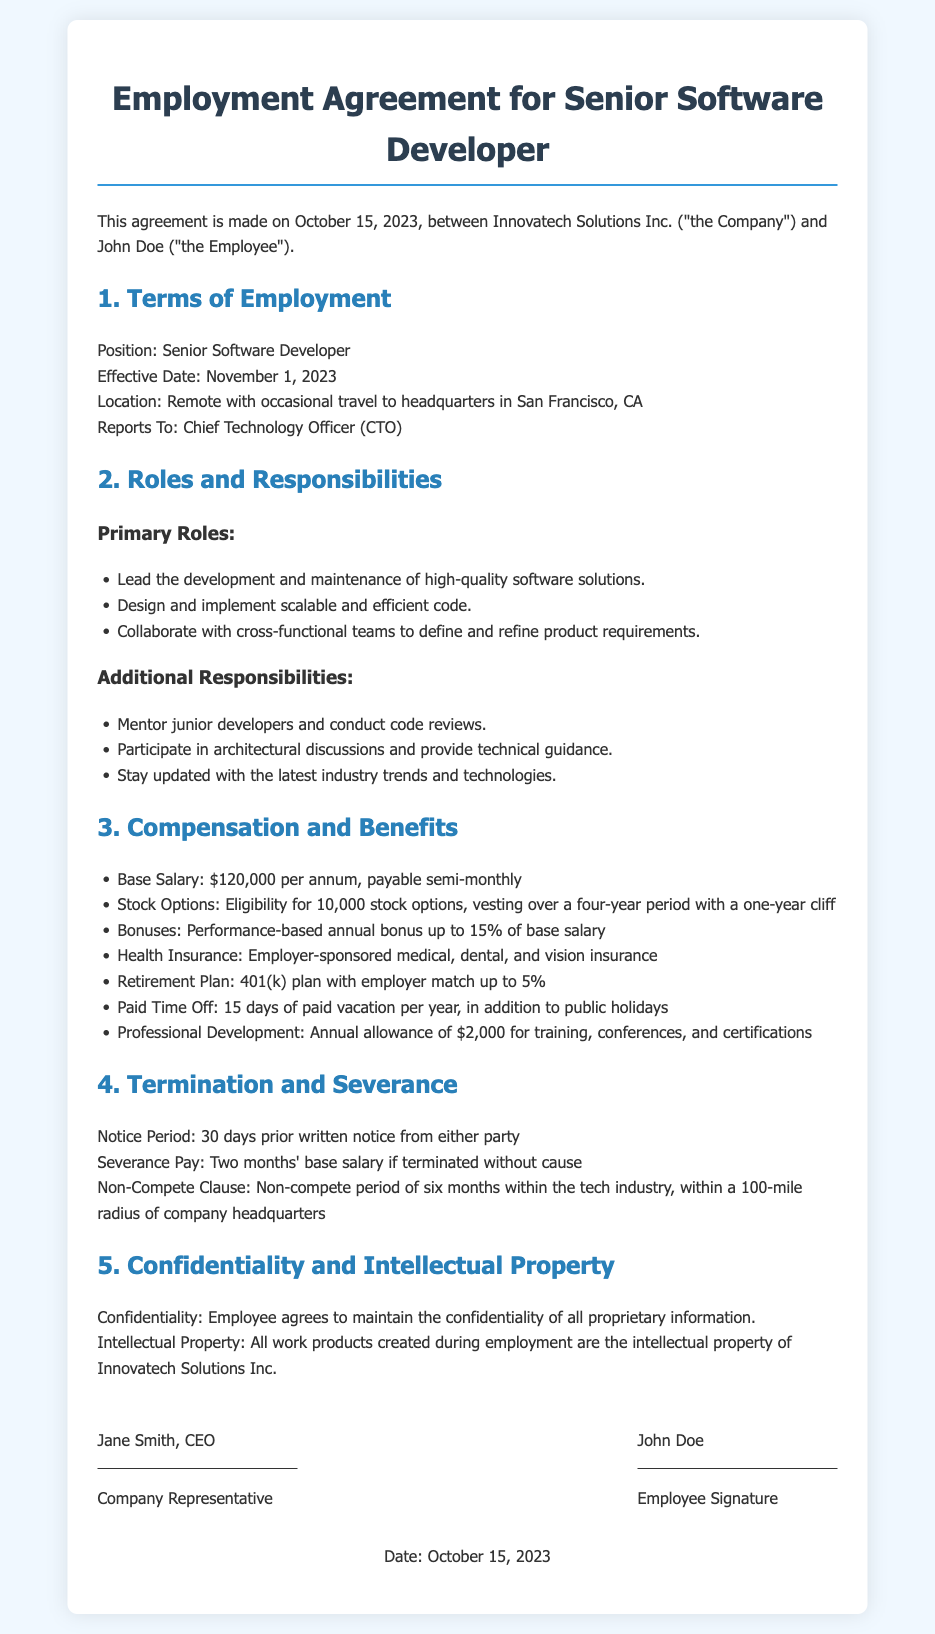What is the effective date of employment? The effective date is mentioned in the terms of employment section of the document.
Answer: November 1, 2023 What is the base salary for the position? The base salary is specified in the compensation and benefits section.
Answer: $120,000 per annum Who does the Senior Software Developer report to? The reporting structure is outlined in the terms of employment section.
Answer: Chief Technology Officer (CTO) How many days of paid vacation does the employee receive? Paid time off details are listed in the compensation and benefits section.
Answer: 15 days What is the notice period for termination? The notice period is stated in the termination and severance section of the document.
Answer: 30 days What percentage of the base salary can be received as a performance-based bonus? The potential bonus percentage is mentioned in the compensation and benefits section.
Answer: 15% How long is the non-compete period? The non-compete duration is described in the termination and severance section.
Answer: Six months What is the annual allowance for professional development? The amount for training and certifications is noted in the compensation and benefits section.
Answer: $2,000 What is the location of the position? The location is specified in the terms of employment section.
Answer: Remote with occasional travel to headquarters in San Francisco, CA 